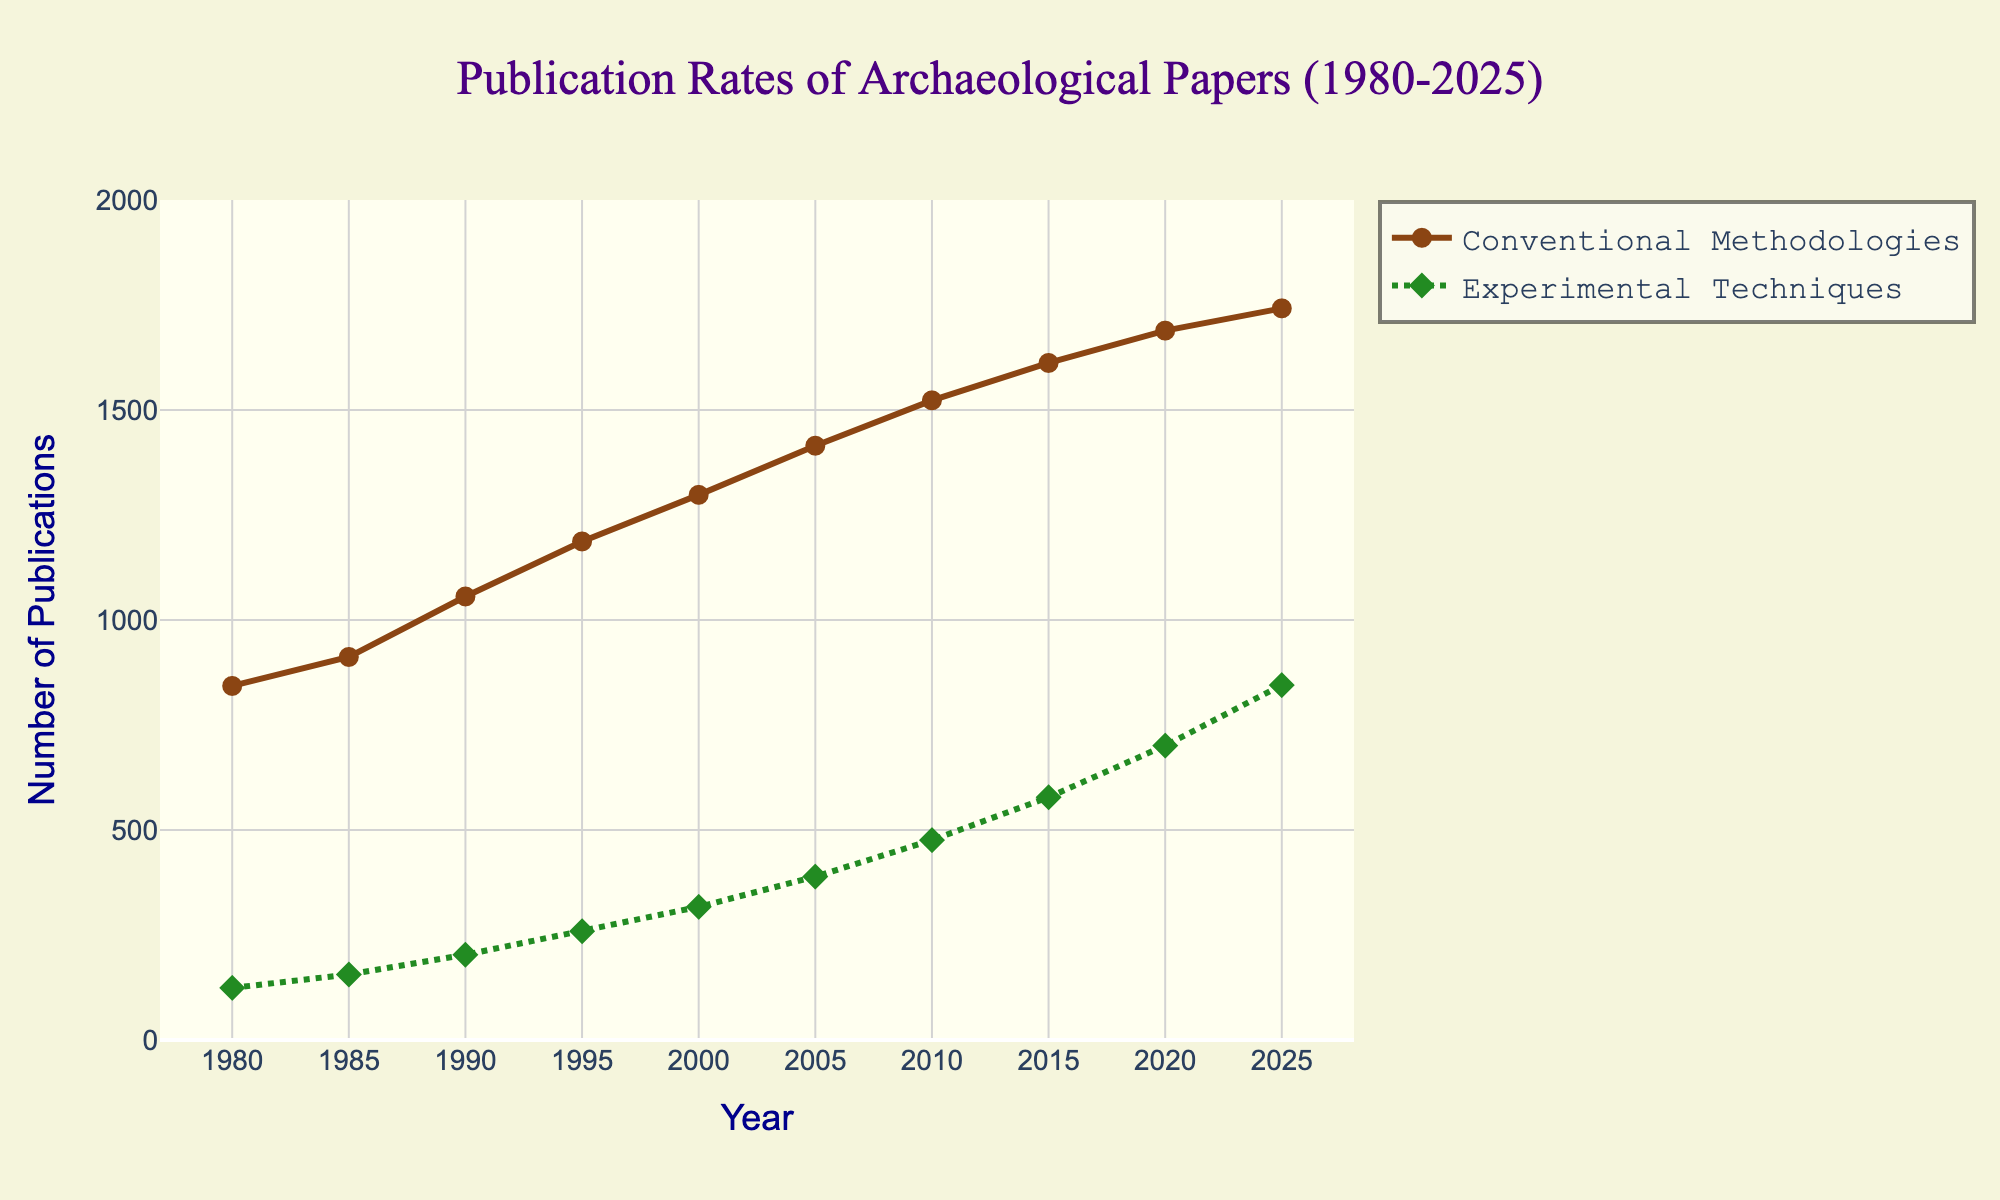What is the total number of publications using Conventional Methodologies and Experimental Techniques in 2020? To find the total number of publications in 2020, we sum the publications using Conventional Methodologies and Experimental Techniques in 2020: 1689 + 701 = 2390.
Answer: 2390 Which technique had a higher publication rate in 1985? Compare the publication rates of Conventional Methodologies (912) to Experimental Techniques (156) in 1985. The publication rate for Conventional Methodologies is higher.
Answer: Conventional Methodologies By which year did Experimental Techniques have more than 500 publications? Look for the year when the number of publications for Experimental Techniques first exceeds 500. In 2015, the number of publications for Experimental Techniques is 578, which is the first instance over 500.
Answer: 2015 What is the difference in publication rates between Conventional Methodologies and Experimental Techniques in 2025? In 2025, the publication rate for Conventional Methodologies is 1742 and for Experimental Techniques, it is 845. The difference is 1742 - 845 = 897.
Answer: 897 How did the trend of publication rates for Conventional Methodologies change from 1995 to 2005? Compare the publication rates in 1995 (1187), 2000 (1298), and 2005 (1415). Notice how the rate increased every period: 1187 to 1298 (increase of 111), and 1298 to 1415 (increase of 117).
Answer: Increased What was the average annual publication rate for Experimental Techniques from 1980 to 2025? To find the average, sum all the publication rates for Experimental Techniques from 1980 to 2025 and divide by the number of years (10). (124 + 156 + 203 + 259 + 317 + 389 + 476 + 578 + 701 + 845)/10 = 4048/10 = 405 approximately.
Answer: 405 Between 2005 and 2010, which technique showed a greater increase in publication rates? Calculate the increase for each technique. Conventional Methodologies: 1523 - 1415 = 108; Experimental Techniques: 476 - 389 = 87. Conventional Methodologies showed a greater increase.
Answer: Conventional Methodologies What are the visually distinguishing features of the line representing Experimental Techniques? The Experimental Techniques line is green, dashed (dot), and uses diamond markers.
Answer: Green line, dashed, diamonds In what year did Conventional Methodologies publications cross 1600? Identify the year when the number of publications for Conventional Methodologies first exceeds 1600. The publication rate in 2015 was 1612.
Answer: 2015 How many more publications were there using Conventional Methodologies than Experimental Techniques in 2000? Subtract the number of publications for Experimental Techniques (317) from those for Conventional Methodologies (1298): 1298 - 317 = 981.
Answer: 981 